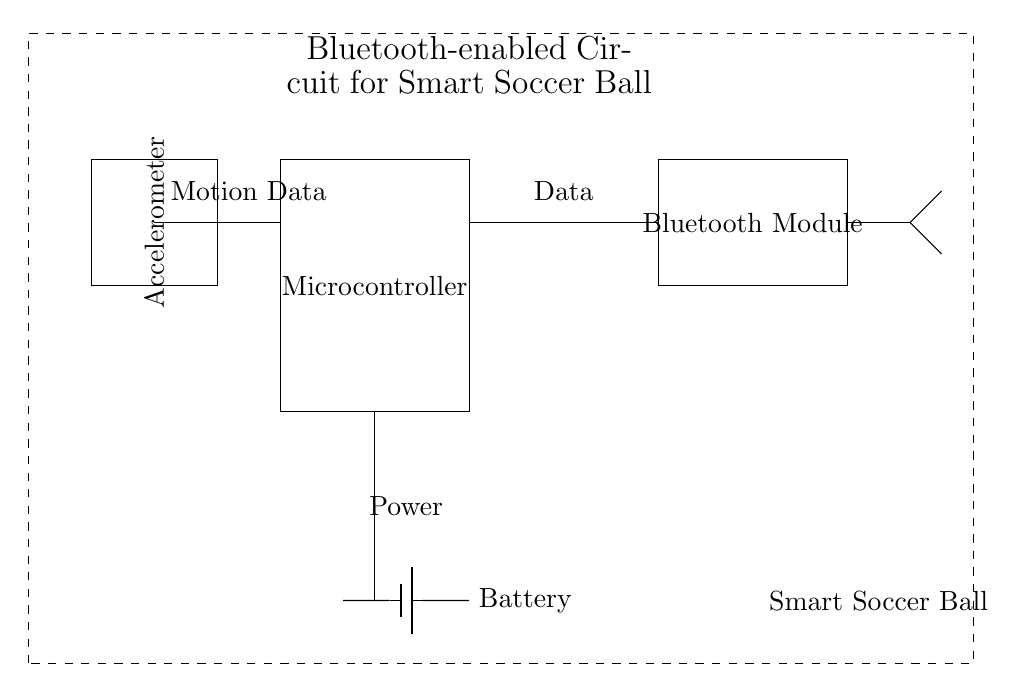What is the main component in this circuit? The main component is the microcontroller, which is responsible for processing the data from the accelerometer and sending it via the Bluetooth module.
Answer: Microcontroller What does the Bluetooth module do in this circuit? The Bluetooth module transmits data wirelessly to another device, allowing the speed and trajectory data from the smart soccer ball to be shared and analyzed.
Answer: Transmits data How many components are connected to the microcontroller? Three components are connected to the microcontroller: the Bluetooth module, the battery, and the accelerometer.
Answer: Three What type of power source is used in this circuit? The circuit uses a battery indicated by the battery symbol, which supplies power to the system.
Answer: Battery How is the accelerometer connected to the microcontroller? The accelerometer is connected to the microcontroller through a wire that connects the two components directly, facilitating the transfer of motion data.
Answer: Directly connected What role does the antenna play in this circuit? The antenna is responsible for broadcasting the data transmitted by the Bluetooth module, allowing communication with nearby devices.
Answer: Broadcasting data 